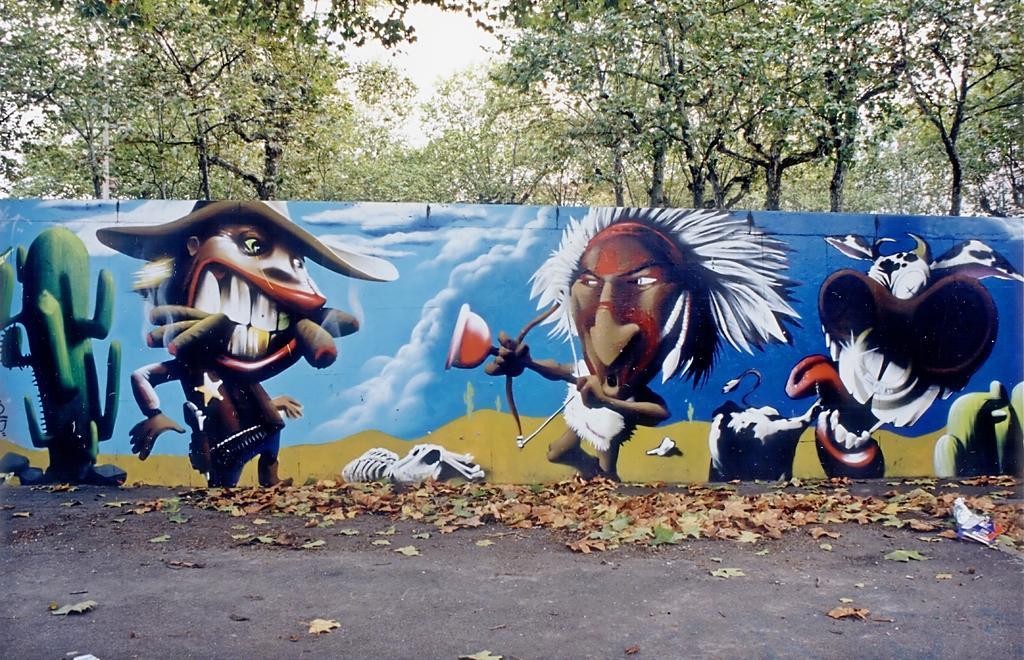Describe this image in one or two sentences. In this picture we can see dried leaves on the ground, painting on the wall, trees and in the background we can see the sky. 